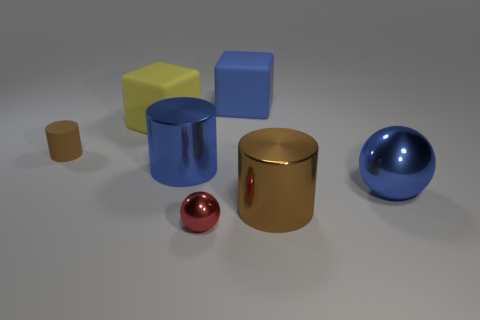What is the shape of the matte object that is the same size as the blue rubber block?
Provide a short and direct response. Cube. Is there a big brown shiny object that has the same shape as the red shiny thing?
Provide a succinct answer. No. The big blue thing that is right of the brown thing right of the tiny brown rubber thing is what shape?
Your answer should be compact. Sphere. The blue rubber object has what shape?
Make the answer very short. Cube. There is a ball right of the metal cylinder that is to the right of the tiny object that is in front of the blue sphere; what is its material?
Provide a succinct answer. Metal. How many other things are the same material as the small sphere?
Your answer should be very brief. 3. There is a tiny object right of the tiny brown cylinder; how many small spheres are behind it?
Your response must be concise. 0. What number of balls are either large blue things or small matte things?
Offer a very short reply. 1. There is a big metallic thing that is on the left side of the large sphere and on the right side of the big blue cube; what color is it?
Offer a very short reply. Brown. Are there any other things of the same color as the small cylinder?
Your answer should be very brief. Yes. 